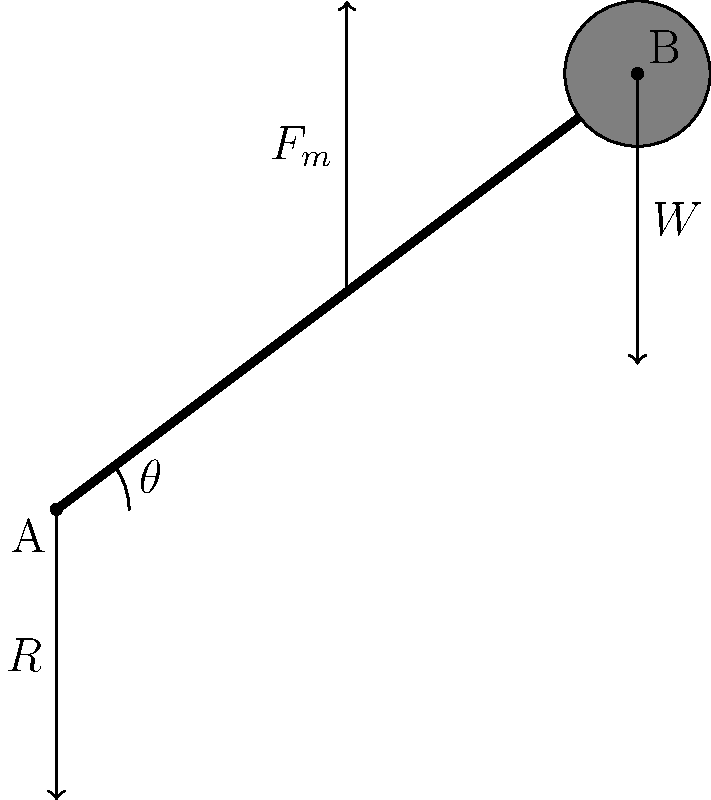In the force diagram of a human arm lifting a weight, the upper arm is fixed, and the forearm is represented by line AB. The weight $W$ is held at point B, the muscle force $F_m$ acts perpendicular to the forearm, and the reaction force $R$ acts at the elbow joint (point A). If the forearm makes an angle $\theta$ with the horizontal, and the weight $W$ is 20 N, calculate the muscle force $F_m$ required to hold the weight in equilibrium when $\theta = 30°$ and the length of the forearm is 30 cm. To solve this problem, we'll use the principles of static equilibrium and moment calculations. Let's approach this step-by-step:

1) First, we need to consider the moment equilibrium about point A (the elbow joint). The sum of moments about A should be zero.

2) The moment due to the weight W:
   $M_W = W \cdot AB \cdot \cos\theta$

3) The moment due to the muscle force $F_m$:
   $M_F = F_m \cdot AB$

4) For equilibrium: $M_W = M_F$

5) Substituting:
   $W \cdot AB \cdot \cos\theta = F_m \cdot AB$

6) Simplifying (AB cancels out):
   $W \cdot \cos\theta = F_m$

7) Now, let's plug in the values:
   $W = 20$ N
   $\theta = 30°$

8) Calculate:
   $F_m = 20 \cdot \cos(30°) = 20 \cdot \frac{\sqrt{3}}{2} = 10\sqrt{3}$ N

9) To get a decimal approximation:
   $F_m \approx 17.32$ N

Note: The length of the forearm (30 cm) wasn't needed for this calculation, as it cancels out in the moment equation. However, it would be necessary if we needed to calculate the reaction force at the elbow.
Answer: $F_m = 10\sqrt{3}$ N or approximately 17.32 N 